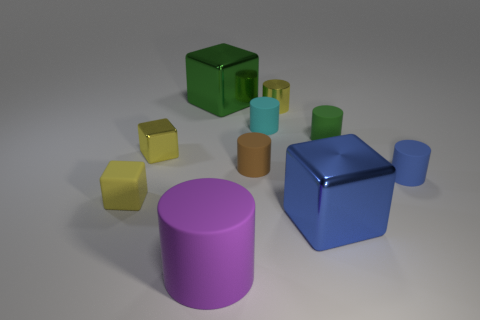Subtract all green blocks. How many blocks are left? 3 Subtract all brown rubber cylinders. How many cylinders are left? 5 Subtract 1 cylinders. How many cylinders are left? 5 Subtract all blue cylinders. Subtract all red blocks. How many cylinders are left? 5 Subtract 0 red blocks. How many objects are left? 10 Subtract all cubes. How many objects are left? 6 Subtract all brown rubber objects. Subtract all yellow shiny blocks. How many objects are left? 8 Add 4 green shiny objects. How many green shiny objects are left? 5 Add 4 shiny blocks. How many shiny blocks exist? 7 